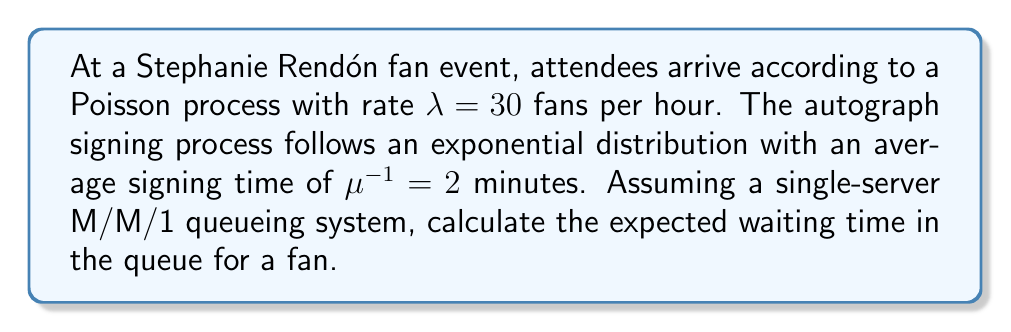Can you answer this question? To solve this problem, we'll use the M/M/1 queueing model and follow these steps:

1. Convert units to be consistent:
   $\lambda = 30$ fans/hour = $0.5$ fans/minute
   $\mu = \frac{1}{2}$ = $0.5$ fans/minute

2. Calculate the utilization factor $\rho$:
   $\rho = \frac{\lambda}{\mu} = \frac{0.5}{0.5} = 1$

3. Use the formula for expected waiting time in queue for an M/M/1 system:
   $W_q = \frac{\rho}{\mu(1-\rho)}$

4. Substitute the values:
   $W_q = \frac{1}{0.5(1-1)} = \frac{1}{0} = \infty$

5. Interpret the result:
   Since $\rho = 1$, the system is at its capacity limit. The queue will grow indefinitely, and the expected waiting time approaches infinity.

In practice, this means the current setup cannot handle the incoming fan traffic, and changes would be needed (e.g., multiple servers or faster signing times) to create a stable queueing system.
Answer: $W_q = \infty$ minutes 